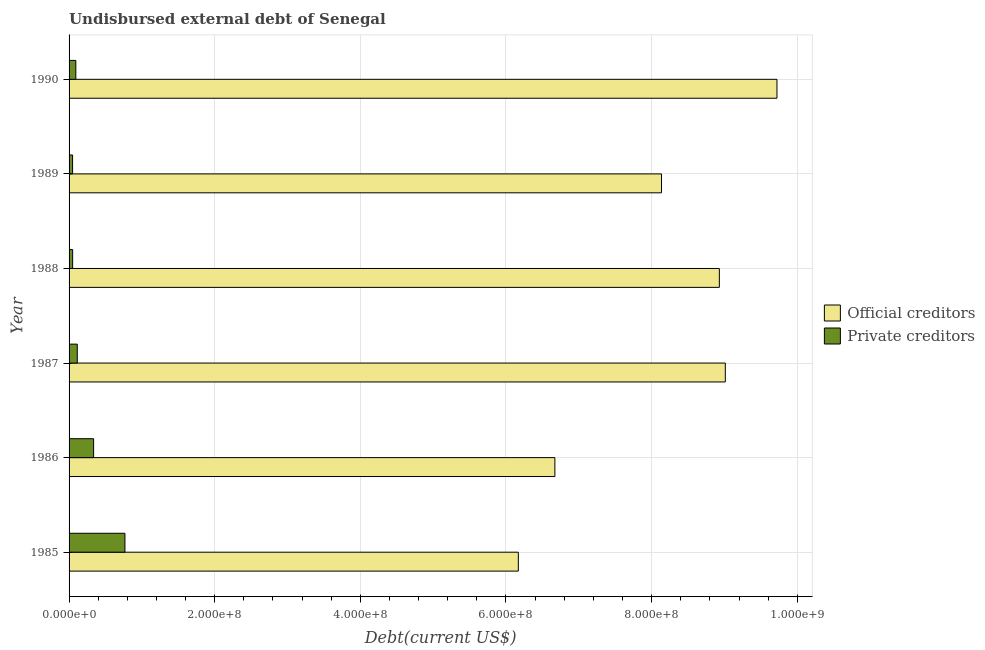How many groups of bars are there?
Your answer should be very brief. 6. Are the number of bars per tick equal to the number of legend labels?
Offer a very short reply. Yes. Are the number of bars on each tick of the Y-axis equal?
Your answer should be compact. Yes. How many bars are there on the 4th tick from the bottom?
Make the answer very short. 2. In how many cases, is the number of bars for a given year not equal to the number of legend labels?
Your answer should be very brief. 0. What is the undisbursed external debt of official creditors in 1990?
Ensure brevity in your answer.  9.72e+08. Across all years, what is the maximum undisbursed external debt of private creditors?
Keep it short and to the point. 7.67e+07. Across all years, what is the minimum undisbursed external debt of official creditors?
Ensure brevity in your answer.  6.17e+08. In which year was the undisbursed external debt of private creditors maximum?
Your response must be concise. 1985. In which year was the undisbursed external debt of private creditors minimum?
Make the answer very short. 1989. What is the total undisbursed external debt of official creditors in the graph?
Offer a very short reply. 4.86e+09. What is the difference between the undisbursed external debt of private creditors in 1986 and that in 1989?
Provide a short and direct response. 2.89e+07. What is the difference between the undisbursed external debt of official creditors in 1986 and the undisbursed external debt of private creditors in 1987?
Provide a succinct answer. 6.56e+08. What is the average undisbursed external debt of official creditors per year?
Provide a short and direct response. 8.11e+08. In the year 1990, what is the difference between the undisbursed external debt of private creditors and undisbursed external debt of official creditors?
Provide a short and direct response. -9.63e+08. What is the ratio of the undisbursed external debt of private creditors in 1986 to that in 1989?
Keep it short and to the point. 6.99. What is the difference between the highest and the second highest undisbursed external debt of private creditors?
Keep it short and to the point. 4.30e+07. What is the difference between the highest and the lowest undisbursed external debt of private creditors?
Make the answer very short. 7.19e+07. Is the sum of the undisbursed external debt of private creditors in 1986 and 1990 greater than the maximum undisbursed external debt of official creditors across all years?
Make the answer very short. No. What does the 1st bar from the top in 1989 represents?
Provide a short and direct response. Private creditors. What does the 1st bar from the bottom in 1988 represents?
Offer a very short reply. Official creditors. Are all the bars in the graph horizontal?
Your answer should be very brief. Yes. How many years are there in the graph?
Ensure brevity in your answer.  6. Are the values on the major ticks of X-axis written in scientific E-notation?
Your answer should be very brief. Yes. Does the graph contain any zero values?
Your response must be concise. No. What is the title of the graph?
Offer a very short reply. Undisbursed external debt of Senegal. Does "Nitrous oxide" appear as one of the legend labels in the graph?
Offer a very short reply. No. What is the label or title of the X-axis?
Your answer should be very brief. Debt(current US$). What is the label or title of the Y-axis?
Keep it short and to the point. Year. What is the Debt(current US$) in Official creditors in 1985?
Offer a very short reply. 6.17e+08. What is the Debt(current US$) of Private creditors in 1985?
Make the answer very short. 7.67e+07. What is the Debt(current US$) of Official creditors in 1986?
Provide a short and direct response. 6.67e+08. What is the Debt(current US$) in Private creditors in 1986?
Your response must be concise. 3.37e+07. What is the Debt(current US$) of Official creditors in 1987?
Offer a very short reply. 9.01e+08. What is the Debt(current US$) in Private creditors in 1987?
Make the answer very short. 1.13e+07. What is the Debt(current US$) in Official creditors in 1988?
Give a very brief answer. 8.93e+08. What is the Debt(current US$) of Private creditors in 1988?
Provide a succinct answer. 4.89e+06. What is the Debt(current US$) in Official creditors in 1989?
Give a very brief answer. 8.14e+08. What is the Debt(current US$) of Private creditors in 1989?
Provide a succinct answer. 4.82e+06. What is the Debt(current US$) in Official creditors in 1990?
Offer a terse response. 9.72e+08. What is the Debt(current US$) of Private creditors in 1990?
Offer a terse response. 9.27e+06. Across all years, what is the maximum Debt(current US$) of Official creditors?
Offer a terse response. 9.72e+08. Across all years, what is the maximum Debt(current US$) of Private creditors?
Your answer should be very brief. 7.67e+07. Across all years, what is the minimum Debt(current US$) in Official creditors?
Offer a terse response. 6.17e+08. Across all years, what is the minimum Debt(current US$) of Private creditors?
Provide a succinct answer. 4.82e+06. What is the total Debt(current US$) in Official creditors in the graph?
Provide a short and direct response. 4.86e+09. What is the total Debt(current US$) of Private creditors in the graph?
Give a very brief answer. 1.41e+08. What is the difference between the Debt(current US$) of Official creditors in 1985 and that in 1986?
Offer a very short reply. -5.02e+07. What is the difference between the Debt(current US$) in Private creditors in 1985 and that in 1986?
Keep it short and to the point. 4.30e+07. What is the difference between the Debt(current US$) of Official creditors in 1985 and that in 1987?
Your answer should be very brief. -2.84e+08. What is the difference between the Debt(current US$) in Private creditors in 1985 and that in 1987?
Ensure brevity in your answer.  6.54e+07. What is the difference between the Debt(current US$) in Official creditors in 1985 and that in 1988?
Ensure brevity in your answer.  -2.76e+08. What is the difference between the Debt(current US$) of Private creditors in 1985 and that in 1988?
Offer a very short reply. 7.18e+07. What is the difference between the Debt(current US$) in Official creditors in 1985 and that in 1989?
Offer a very short reply. -1.97e+08. What is the difference between the Debt(current US$) in Private creditors in 1985 and that in 1989?
Offer a very short reply. 7.19e+07. What is the difference between the Debt(current US$) of Official creditors in 1985 and that in 1990?
Your response must be concise. -3.55e+08. What is the difference between the Debt(current US$) in Private creditors in 1985 and that in 1990?
Provide a short and direct response. 6.74e+07. What is the difference between the Debt(current US$) in Official creditors in 1986 and that in 1987?
Give a very brief answer. -2.34e+08. What is the difference between the Debt(current US$) of Private creditors in 1986 and that in 1987?
Offer a terse response. 2.24e+07. What is the difference between the Debt(current US$) of Official creditors in 1986 and that in 1988?
Ensure brevity in your answer.  -2.26e+08. What is the difference between the Debt(current US$) in Private creditors in 1986 and that in 1988?
Provide a short and direct response. 2.88e+07. What is the difference between the Debt(current US$) in Official creditors in 1986 and that in 1989?
Your answer should be very brief. -1.46e+08. What is the difference between the Debt(current US$) in Private creditors in 1986 and that in 1989?
Ensure brevity in your answer.  2.89e+07. What is the difference between the Debt(current US$) of Official creditors in 1986 and that in 1990?
Give a very brief answer. -3.05e+08. What is the difference between the Debt(current US$) of Private creditors in 1986 and that in 1990?
Offer a terse response. 2.44e+07. What is the difference between the Debt(current US$) of Official creditors in 1987 and that in 1988?
Ensure brevity in your answer.  8.20e+06. What is the difference between the Debt(current US$) in Private creditors in 1987 and that in 1988?
Provide a short and direct response. 6.37e+06. What is the difference between the Debt(current US$) in Official creditors in 1987 and that in 1989?
Provide a short and direct response. 8.76e+07. What is the difference between the Debt(current US$) of Private creditors in 1987 and that in 1989?
Your answer should be very brief. 6.45e+06. What is the difference between the Debt(current US$) in Official creditors in 1987 and that in 1990?
Provide a succinct answer. -7.10e+07. What is the difference between the Debt(current US$) of Private creditors in 1987 and that in 1990?
Offer a terse response. 1.99e+06. What is the difference between the Debt(current US$) of Official creditors in 1988 and that in 1989?
Your response must be concise. 7.94e+07. What is the difference between the Debt(current US$) of Private creditors in 1988 and that in 1989?
Ensure brevity in your answer.  7.40e+04. What is the difference between the Debt(current US$) of Official creditors in 1988 and that in 1990?
Provide a short and direct response. -7.92e+07. What is the difference between the Debt(current US$) of Private creditors in 1988 and that in 1990?
Offer a terse response. -4.38e+06. What is the difference between the Debt(current US$) in Official creditors in 1989 and that in 1990?
Make the answer very short. -1.59e+08. What is the difference between the Debt(current US$) of Private creditors in 1989 and that in 1990?
Keep it short and to the point. -4.45e+06. What is the difference between the Debt(current US$) of Official creditors in 1985 and the Debt(current US$) of Private creditors in 1986?
Offer a very short reply. 5.83e+08. What is the difference between the Debt(current US$) in Official creditors in 1985 and the Debt(current US$) in Private creditors in 1987?
Ensure brevity in your answer.  6.06e+08. What is the difference between the Debt(current US$) in Official creditors in 1985 and the Debt(current US$) in Private creditors in 1988?
Make the answer very short. 6.12e+08. What is the difference between the Debt(current US$) of Official creditors in 1985 and the Debt(current US$) of Private creditors in 1989?
Keep it short and to the point. 6.12e+08. What is the difference between the Debt(current US$) in Official creditors in 1985 and the Debt(current US$) in Private creditors in 1990?
Offer a terse response. 6.08e+08. What is the difference between the Debt(current US$) in Official creditors in 1986 and the Debt(current US$) in Private creditors in 1987?
Make the answer very short. 6.56e+08. What is the difference between the Debt(current US$) of Official creditors in 1986 and the Debt(current US$) of Private creditors in 1988?
Provide a succinct answer. 6.62e+08. What is the difference between the Debt(current US$) in Official creditors in 1986 and the Debt(current US$) in Private creditors in 1989?
Your answer should be very brief. 6.62e+08. What is the difference between the Debt(current US$) of Official creditors in 1986 and the Debt(current US$) of Private creditors in 1990?
Make the answer very short. 6.58e+08. What is the difference between the Debt(current US$) of Official creditors in 1987 and the Debt(current US$) of Private creditors in 1988?
Your answer should be very brief. 8.96e+08. What is the difference between the Debt(current US$) of Official creditors in 1987 and the Debt(current US$) of Private creditors in 1989?
Your answer should be very brief. 8.96e+08. What is the difference between the Debt(current US$) in Official creditors in 1987 and the Debt(current US$) in Private creditors in 1990?
Give a very brief answer. 8.92e+08. What is the difference between the Debt(current US$) of Official creditors in 1988 and the Debt(current US$) of Private creditors in 1989?
Your answer should be compact. 8.88e+08. What is the difference between the Debt(current US$) in Official creditors in 1988 and the Debt(current US$) in Private creditors in 1990?
Keep it short and to the point. 8.84e+08. What is the difference between the Debt(current US$) in Official creditors in 1989 and the Debt(current US$) in Private creditors in 1990?
Your response must be concise. 8.04e+08. What is the average Debt(current US$) in Official creditors per year?
Ensure brevity in your answer.  8.11e+08. What is the average Debt(current US$) of Private creditors per year?
Your response must be concise. 2.34e+07. In the year 1985, what is the difference between the Debt(current US$) in Official creditors and Debt(current US$) in Private creditors?
Your response must be concise. 5.40e+08. In the year 1986, what is the difference between the Debt(current US$) of Official creditors and Debt(current US$) of Private creditors?
Make the answer very short. 6.33e+08. In the year 1987, what is the difference between the Debt(current US$) in Official creditors and Debt(current US$) in Private creditors?
Make the answer very short. 8.90e+08. In the year 1988, what is the difference between the Debt(current US$) in Official creditors and Debt(current US$) in Private creditors?
Your response must be concise. 8.88e+08. In the year 1989, what is the difference between the Debt(current US$) in Official creditors and Debt(current US$) in Private creditors?
Give a very brief answer. 8.09e+08. In the year 1990, what is the difference between the Debt(current US$) of Official creditors and Debt(current US$) of Private creditors?
Offer a very short reply. 9.63e+08. What is the ratio of the Debt(current US$) in Official creditors in 1985 to that in 1986?
Ensure brevity in your answer.  0.92. What is the ratio of the Debt(current US$) in Private creditors in 1985 to that in 1986?
Provide a short and direct response. 2.28. What is the ratio of the Debt(current US$) of Official creditors in 1985 to that in 1987?
Your answer should be compact. 0.68. What is the ratio of the Debt(current US$) in Private creditors in 1985 to that in 1987?
Offer a very short reply. 6.81. What is the ratio of the Debt(current US$) of Official creditors in 1985 to that in 1988?
Offer a very short reply. 0.69. What is the ratio of the Debt(current US$) in Private creditors in 1985 to that in 1988?
Give a very brief answer. 15.67. What is the ratio of the Debt(current US$) in Official creditors in 1985 to that in 1989?
Your response must be concise. 0.76. What is the ratio of the Debt(current US$) of Private creditors in 1985 to that in 1989?
Make the answer very short. 15.92. What is the ratio of the Debt(current US$) in Official creditors in 1985 to that in 1990?
Provide a succinct answer. 0.63. What is the ratio of the Debt(current US$) in Private creditors in 1985 to that in 1990?
Make the answer very short. 8.27. What is the ratio of the Debt(current US$) in Official creditors in 1986 to that in 1987?
Provide a short and direct response. 0.74. What is the ratio of the Debt(current US$) in Private creditors in 1986 to that in 1987?
Your response must be concise. 2.99. What is the ratio of the Debt(current US$) of Official creditors in 1986 to that in 1988?
Provide a succinct answer. 0.75. What is the ratio of the Debt(current US$) of Private creditors in 1986 to that in 1988?
Ensure brevity in your answer.  6.88. What is the ratio of the Debt(current US$) in Official creditors in 1986 to that in 1989?
Offer a terse response. 0.82. What is the ratio of the Debt(current US$) of Private creditors in 1986 to that in 1989?
Provide a short and direct response. 6.99. What is the ratio of the Debt(current US$) of Official creditors in 1986 to that in 1990?
Ensure brevity in your answer.  0.69. What is the ratio of the Debt(current US$) of Private creditors in 1986 to that in 1990?
Offer a very short reply. 3.63. What is the ratio of the Debt(current US$) in Official creditors in 1987 to that in 1988?
Your response must be concise. 1.01. What is the ratio of the Debt(current US$) in Private creditors in 1987 to that in 1988?
Offer a terse response. 2.3. What is the ratio of the Debt(current US$) of Official creditors in 1987 to that in 1989?
Offer a terse response. 1.11. What is the ratio of the Debt(current US$) of Private creditors in 1987 to that in 1989?
Provide a succinct answer. 2.34. What is the ratio of the Debt(current US$) of Official creditors in 1987 to that in 1990?
Offer a very short reply. 0.93. What is the ratio of the Debt(current US$) of Private creditors in 1987 to that in 1990?
Ensure brevity in your answer.  1.21. What is the ratio of the Debt(current US$) of Official creditors in 1988 to that in 1989?
Keep it short and to the point. 1.1. What is the ratio of the Debt(current US$) in Private creditors in 1988 to that in 1989?
Give a very brief answer. 1.02. What is the ratio of the Debt(current US$) of Official creditors in 1988 to that in 1990?
Your answer should be very brief. 0.92. What is the ratio of the Debt(current US$) in Private creditors in 1988 to that in 1990?
Provide a short and direct response. 0.53. What is the ratio of the Debt(current US$) in Official creditors in 1989 to that in 1990?
Your answer should be compact. 0.84. What is the ratio of the Debt(current US$) of Private creditors in 1989 to that in 1990?
Your answer should be compact. 0.52. What is the difference between the highest and the second highest Debt(current US$) of Official creditors?
Keep it short and to the point. 7.10e+07. What is the difference between the highest and the second highest Debt(current US$) of Private creditors?
Give a very brief answer. 4.30e+07. What is the difference between the highest and the lowest Debt(current US$) of Official creditors?
Your answer should be compact. 3.55e+08. What is the difference between the highest and the lowest Debt(current US$) in Private creditors?
Give a very brief answer. 7.19e+07. 